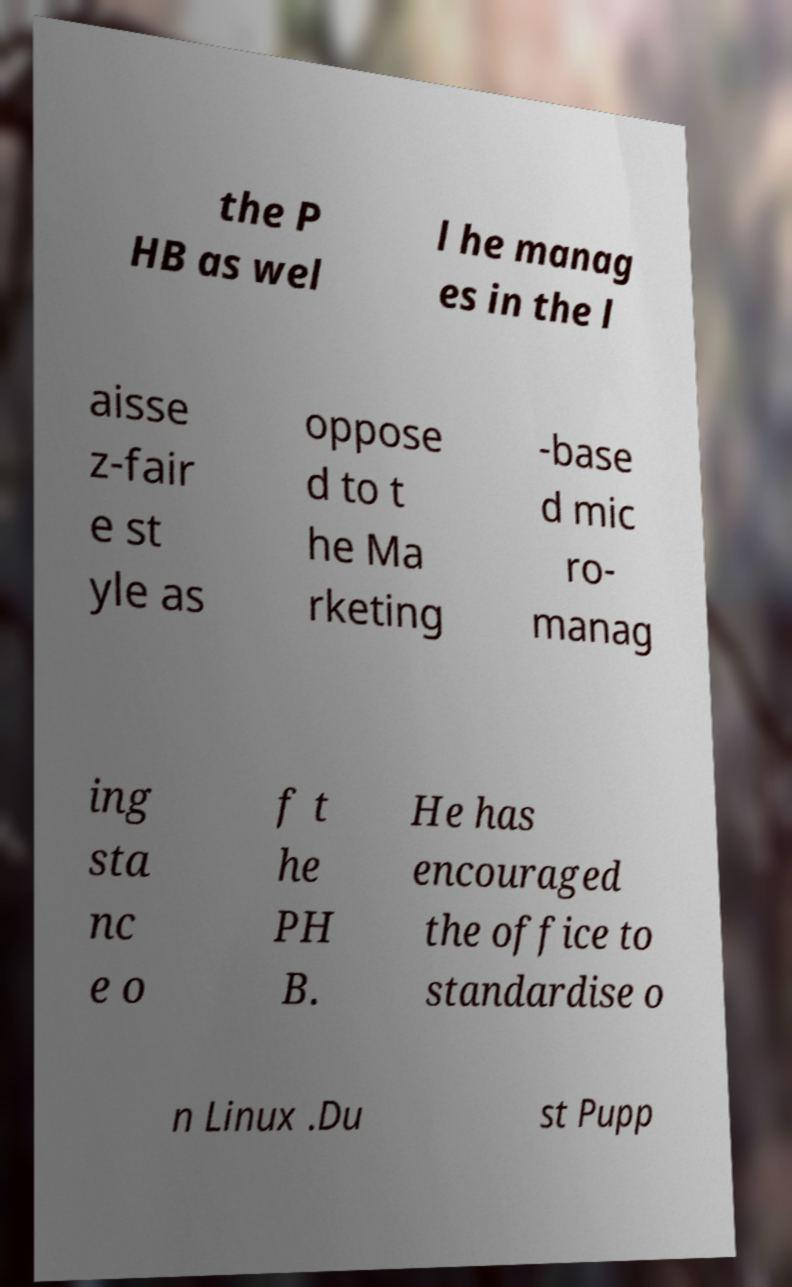What messages or text are displayed in this image? I need them in a readable, typed format. the P HB as wel l he manag es in the l aisse z-fair e st yle as oppose d to t he Ma rketing -base d mic ro- manag ing sta nc e o f t he PH B. He has encouraged the office to standardise o n Linux .Du st Pupp 